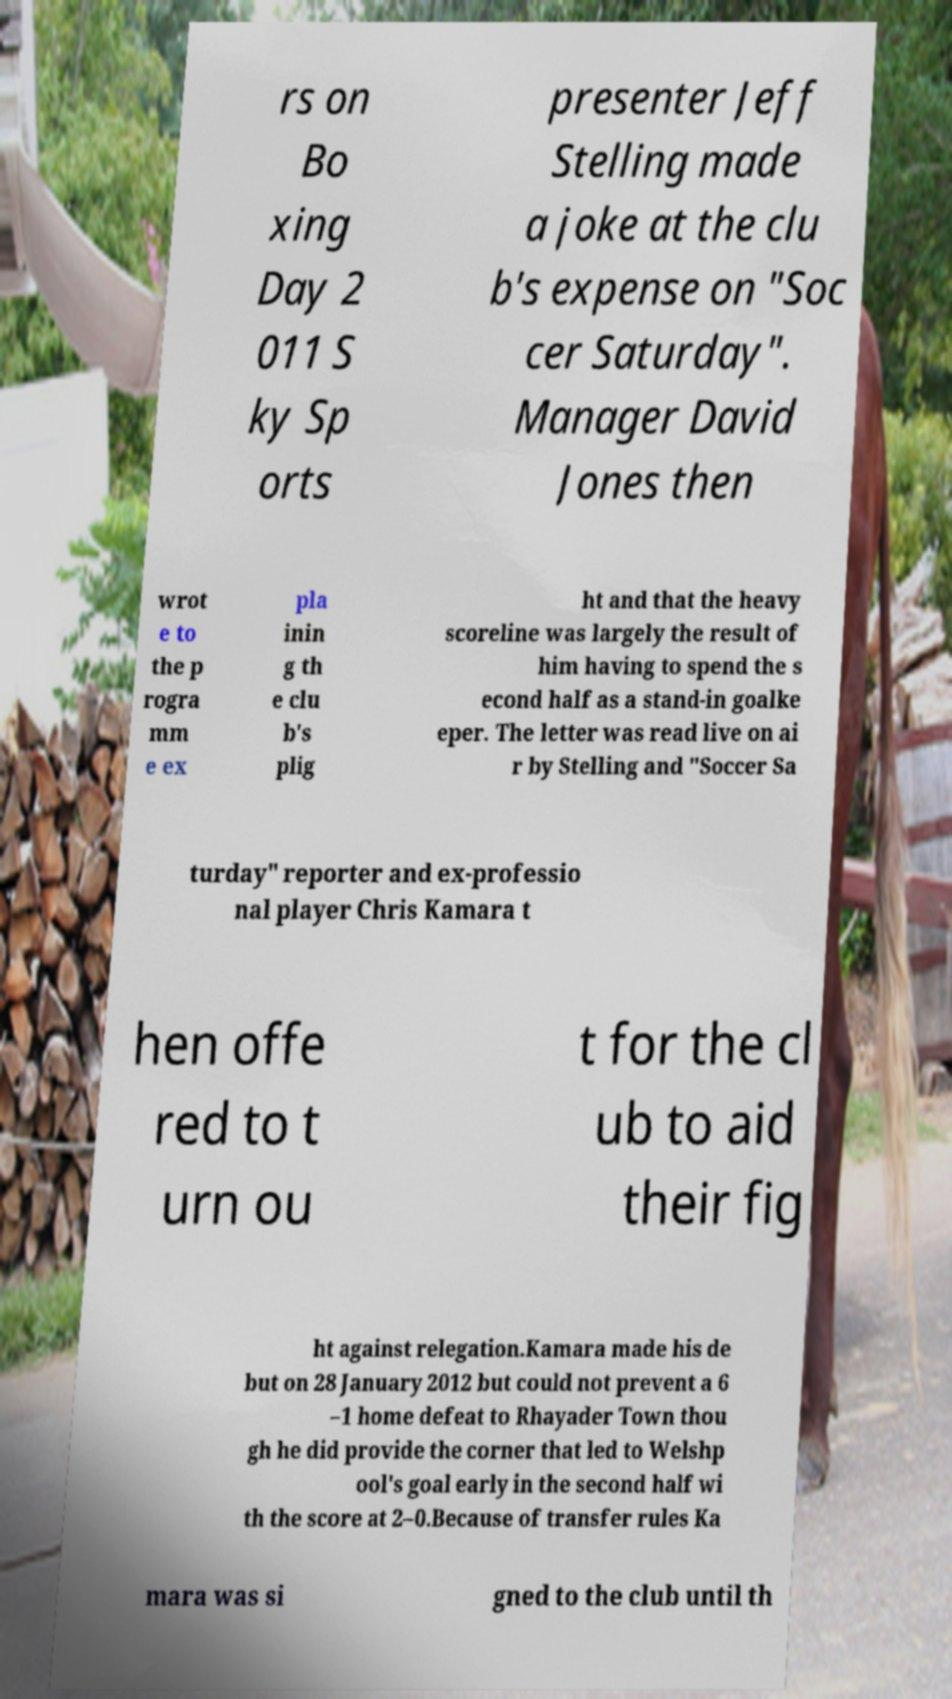Could you extract and type out the text from this image? rs on Bo xing Day 2 011 S ky Sp orts presenter Jeff Stelling made a joke at the clu b's expense on "Soc cer Saturday". Manager David Jones then wrot e to the p rogra mm e ex pla inin g th e clu b's plig ht and that the heavy scoreline was largely the result of him having to spend the s econd half as a stand-in goalke eper. The letter was read live on ai r by Stelling and "Soccer Sa turday" reporter and ex-professio nal player Chris Kamara t hen offe red to t urn ou t for the cl ub to aid their fig ht against relegation.Kamara made his de but on 28 January 2012 but could not prevent a 6 –1 home defeat to Rhayader Town thou gh he did provide the corner that led to Welshp ool's goal early in the second half wi th the score at 2–0.Because of transfer rules Ka mara was si gned to the club until th 